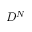Convert formula to latex. <formula><loc_0><loc_0><loc_500><loc_500>D ^ { N }</formula> 